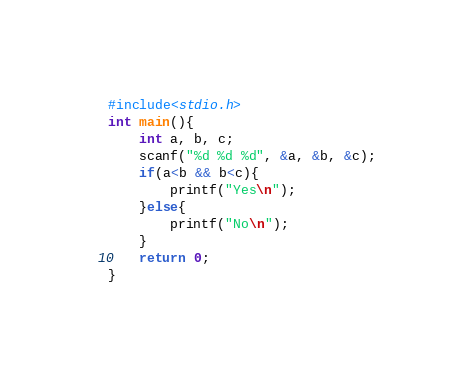Convert code to text. <code><loc_0><loc_0><loc_500><loc_500><_C_>#include<stdio.h>
int main(){
    int a, b, c;
    scanf("%d %d %d", &a, &b, &c);
    if(a<b && b<c){
        printf("Yes\n");
    }else{
        printf("No\n");
    }
    return 0;
}
</code> 